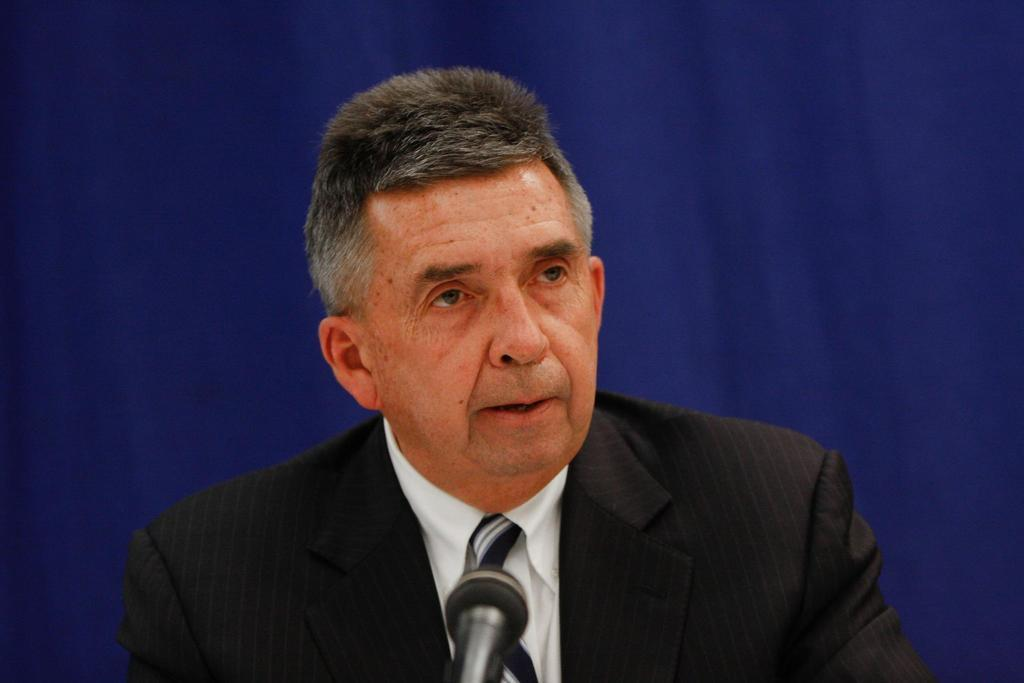Who is present in the image? There is a person in the image. Where is the person located in the image? The person is at the middle of the image. What is the person wearing? The person is wearing a black jacket and a white shirt. What object can be seen at the bottom of the image? There is a microphone at the bottom of the image. How many men are standing on the roof in the image? There is no roof or men present in the image. 